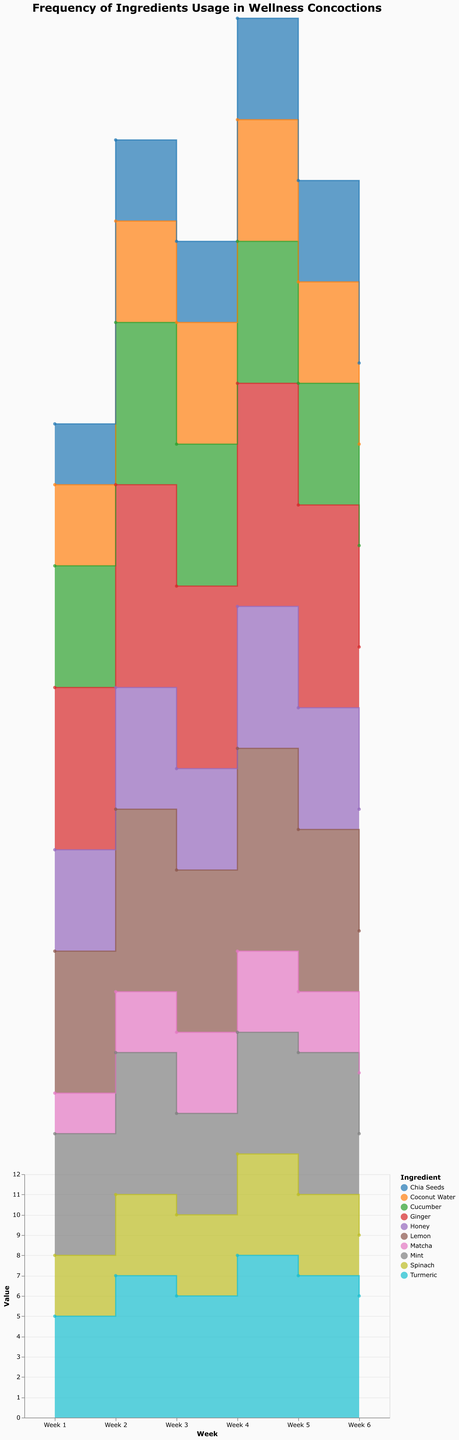what is the title of the figure? The title is usually displayed prominently at the top of a figure and is in bold font. Here, it reads: "Frequency of Ingredients Usage in Wellness Concoctions".
Answer: Frequency of Ingredients Usage in Wellness Concoctions Which ingredient had the highest usage in Week 4? To find this, look at the Week 4 values for each ingredient and identify the maximum value. Ginger has the highest value of 11.
Answer: Ginger What is the total usage of Mint over the six weeks? Sum the frequencies of Mint over the six weeks: 6 (Week 1) + 7 (Week 2) + 5 (Week 3) + 6 (Week 4) + 7 (Week 5) + 5 (Week 6) = 36
Answer: 36 Which ingredient showed a constant frequency between at least two consecutive weeks? Scan the values of each ingredient and look for repeated frequencies between two consecutive weeks. Coconut Water maintains a constant frequency of 6 for Week 4 and Week 5.
Answer: Coconut Water How does the usage trend of Spinach compare to that of Matcha? Observe the usage values of Spinach and Matcha across the six weeks. Spinach starts higher but drops by the last week, whereas Matcha shows a gradual increase followed by stabilization.
Answer: Spinach starts higher, then decreases; Matcha gradually increases and stabilizes What was the average usage of Lemon over the six weeks? Sum the usage values of Lemon over six weeks and divide by 6: (7 + 9 + 8 + 10 + 8 + 7) / 6 = 49 / 6 ≈ 8.17
Answer: 8.17 Which ingredient had more variability in usage: Turmeric or Honey? Calculate the range (max - min value) for both ingredients. Turmeric has a range of 8 - 5 = 3, and Honey has a range of 7 - 5 = 2. Turmeric has more variability.
Answer: Turmeric Identify the ingredients whose usage peaked in Week 5. Check Week 5 values and compare to other weeks for each ingredient. Lemon, Spinach, and Chia Seeds have their highest values in Week 5.
Answer: Lemon, Spinach, Chia Seeds What is the difference in frequency between Ginger and Chia Seeds in Week 3? Subtract Week 3 value of Chia Seeds from Ginger: 9 - 4 = 5
Answer: 5 